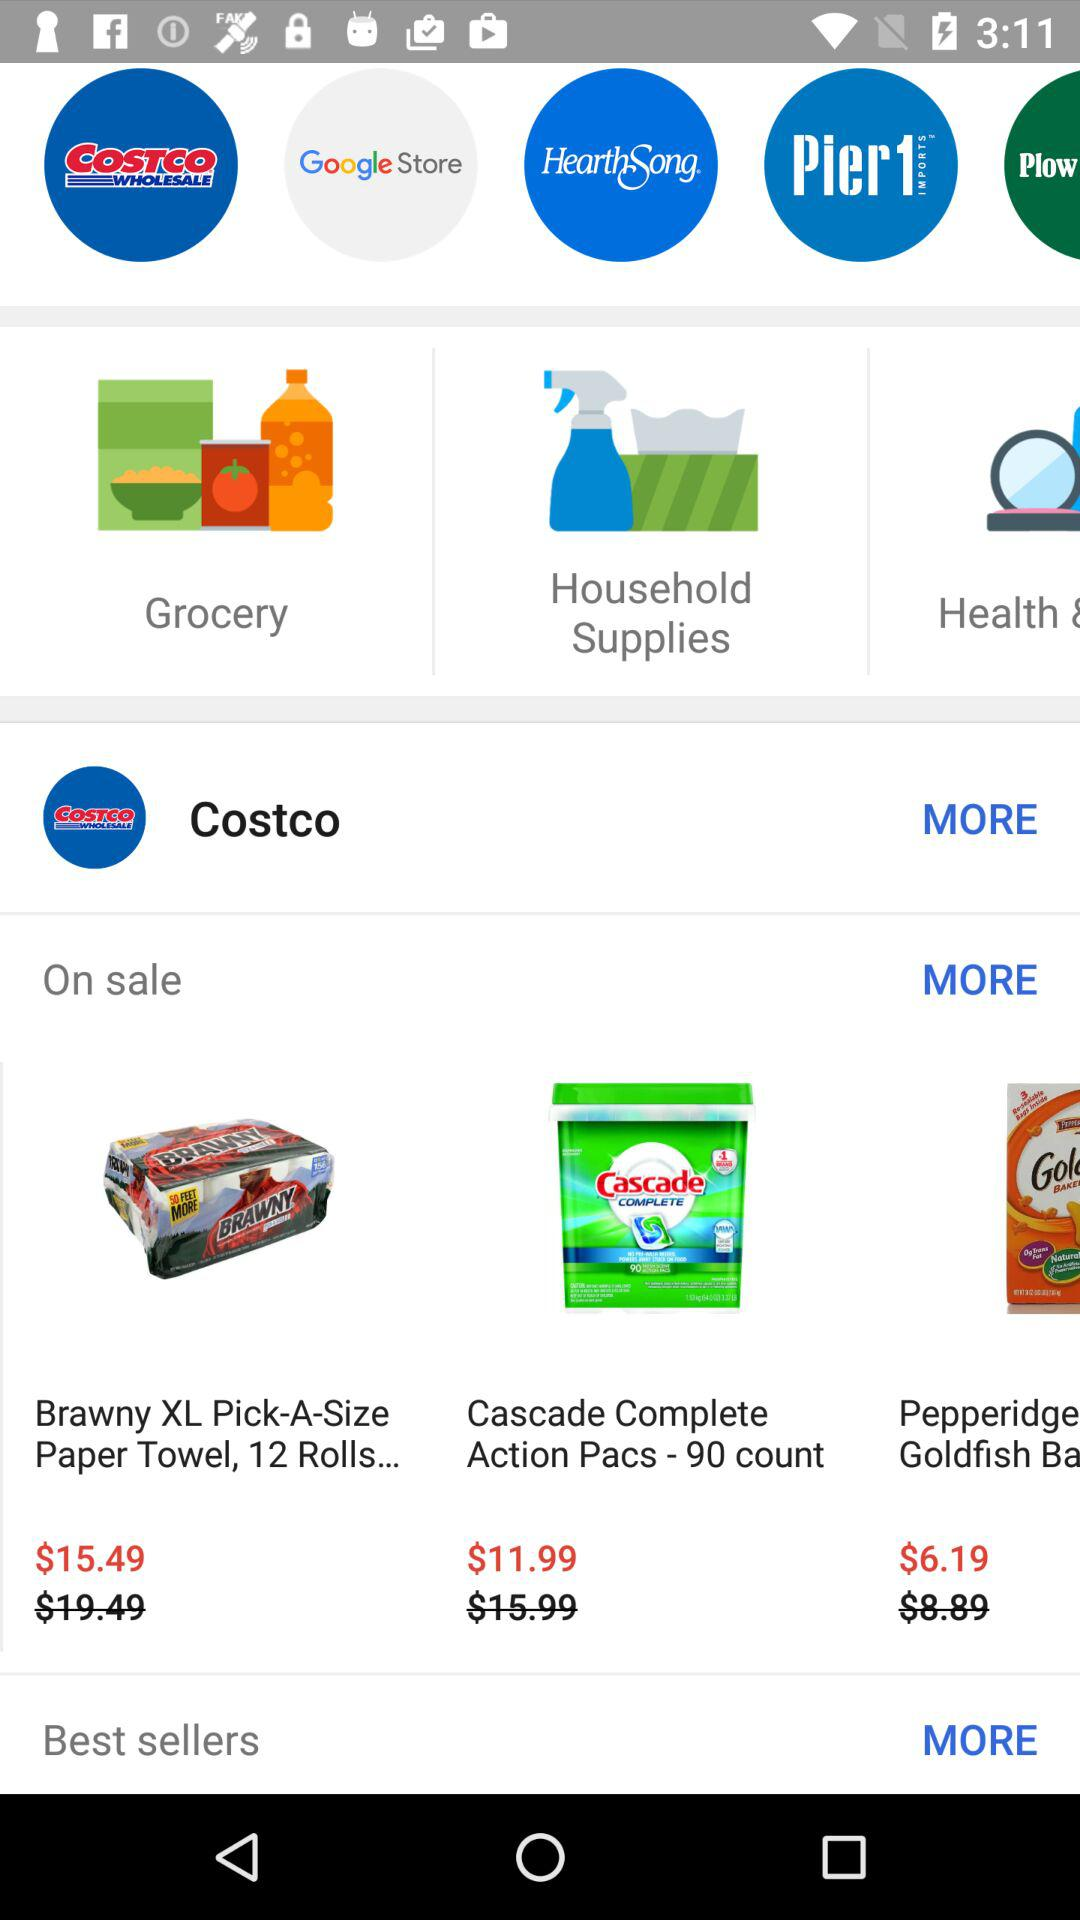What is the price of "Brawny XL Pick-A-Size Paper Towel, 12 Rolls..."? The price of "Brawny XL Pick-A-Size Paper Towel, 12 Rolls..." is $15.49. 